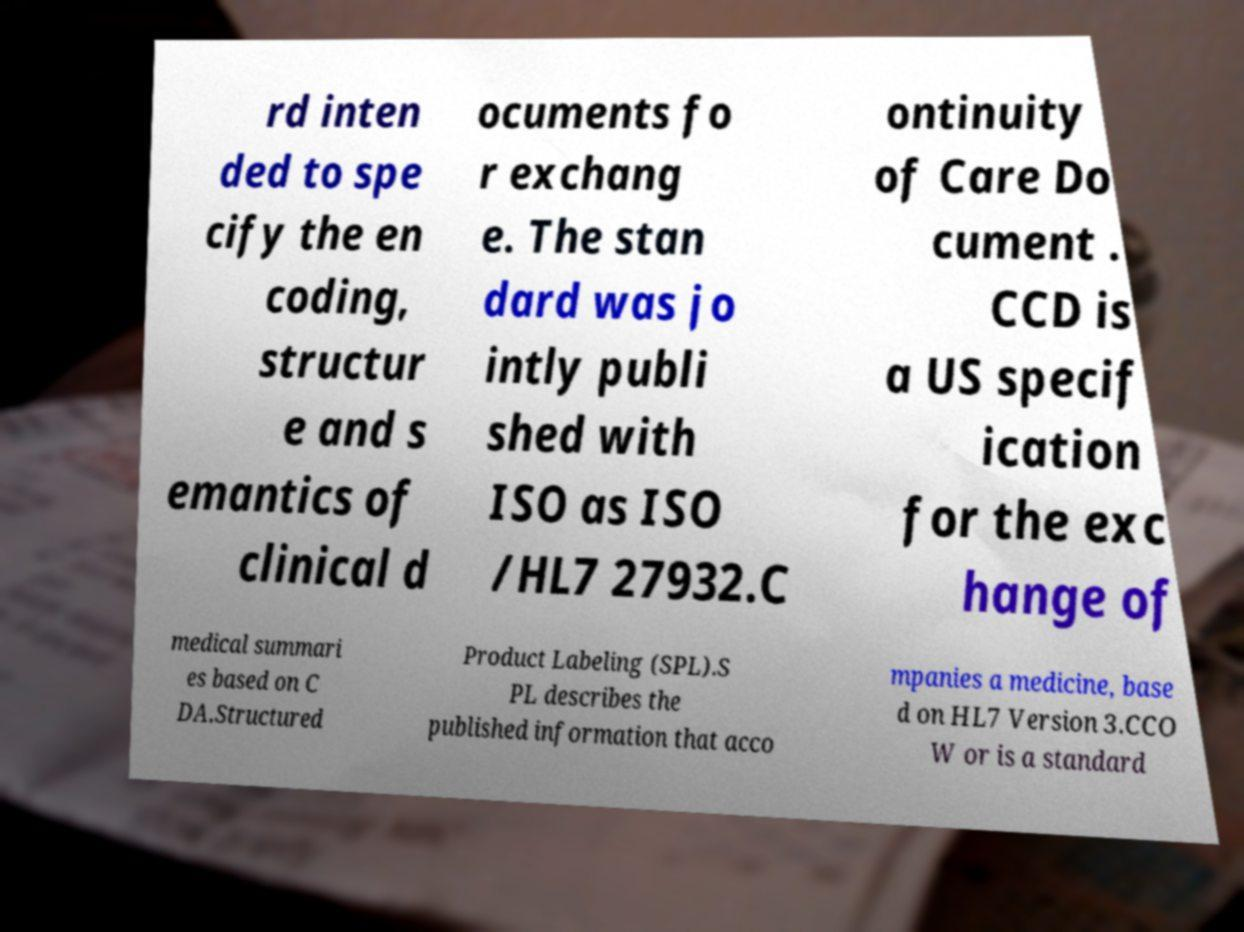Please identify and transcribe the text found in this image. rd inten ded to spe cify the en coding, structur e and s emantics of clinical d ocuments fo r exchang e. The stan dard was jo intly publi shed with ISO as ISO /HL7 27932.C ontinuity of Care Do cument . CCD is a US specif ication for the exc hange of medical summari es based on C DA.Structured Product Labeling (SPL).S PL describes the published information that acco mpanies a medicine, base d on HL7 Version 3.CCO W or is a standard 